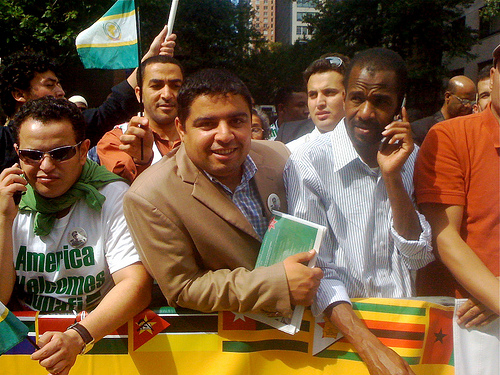What event might these people be attending? Given the presence of flags and the expressions on the people's faces, they might be participating in some form of rally, demonstration, or public gathering to express their views or celebrate a particular cause or event related to their country or community. 